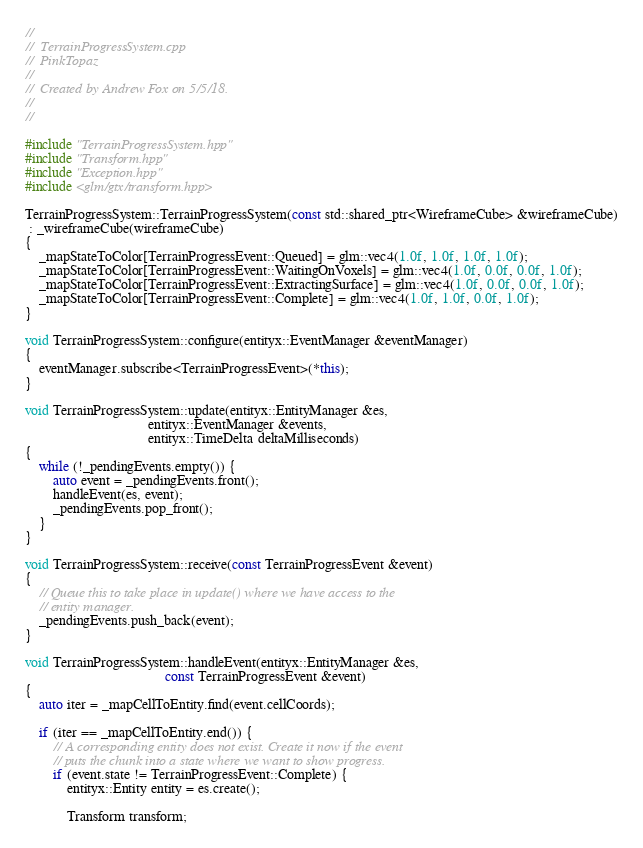<code> <loc_0><loc_0><loc_500><loc_500><_C++_>//
//  TerrainProgressSystem.cpp
//  PinkTopaz
//
//  Created by Andrew Fox on 5/5/18.
//
//

#include "TerrainProgressSystem.hpp"
#include "Transform.hpp"
#include "Exception.hpp"
#include <glm/gtx/transform.hpp>

TerrainProgressSystem::TerrainProgressSystem(const std::shared_ptr<WireframeCube> &wireframeCube)
 : _wireframeCube(wireframeCube)
{
    _mapStateToColor[TerrainProgressEvent::Queued] = glm::vec4(1.0f, 1.0f, 1.0f, 1.0f);
    _mapStateToColor[TerrainProgressEvent::WaitingOnVoxels] = glm::vec4(1.0f, 0.0f, 0.0f, 1.0f);
    _mapStateToColor[TerrainProgressEvent::ExtractingSurface] = glm::vec4(1.0f, 0.0f, 0.0f, 1.0f);
    _mapStateToColor[TerrainProgressEvent::Complete] = glm::vec4(1.0f, 1.0f, 0.0f, 1.0f);
}

void TerrainProgressSystem::configure(entityx::EventManager &eventManager)
{
    eventManager.subscribe<TerrainProgressEvent>(*this);
}

void TerrainProgressSystem::update(entityx::EntityManager &es,
                                   entityx::EventManager &events,
                                   entityx::TimeDelta deltaMilliseconds)
{
    while (!_pendingEvents.empty()) {
        auto event = _pendingEvents.front();
        handleEvent(es, event);
        _pendingEvents.pop_front();
    }
}

void TerrainProgressSystem::receive(const TerrainProgressEvent &event)
{
    // Queue this to take place in update() where we have access to the
    // entity manager.
    _pendingEvents.push_back(event);
}

void TerrainProgressSystem::handleEvent(entityx::EntityManager &es,
                                        const TerrainProgressEvent &event)
{
    auto iter = _mapCellToEntity.find(event.cellCoords);
    
    if (iter == _mapCellToEntity.end()) {
        // A corresponding entity does not exist. Create it now if the event
        // puts the chunk into a state where we want to show progress.
        if (event.state != TerrainProgressEvent::Complete) {
            entityx::Entity entity = es.create();
            
            Transform transform;</code> 